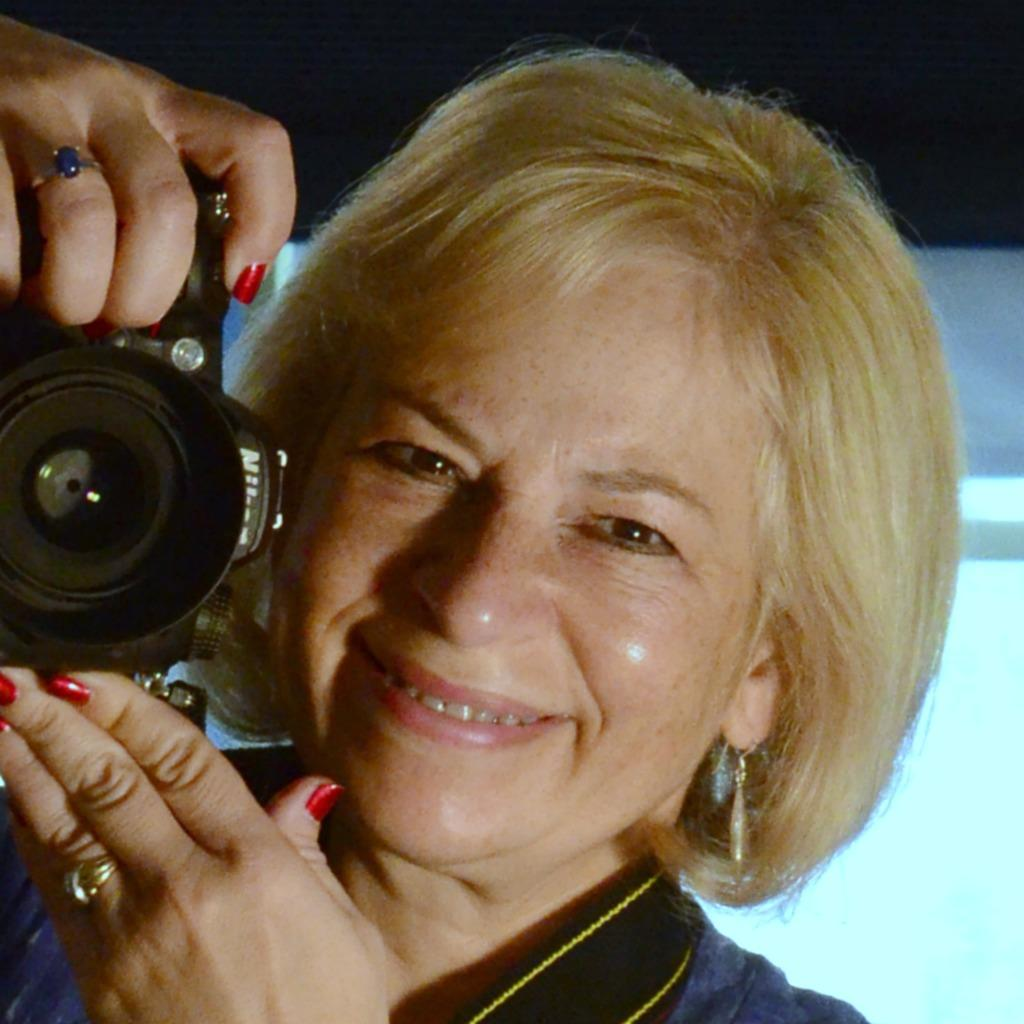Who is present in the image? There is a woman in the image. What is the woman's facial expression? The woman is smiling. What type of accessory is the woman wearing? The woman is wearing earrings. What object is the woman holding in the image? The woman is holding a digital camera. What type of hook can be seen in the image? There is no hook present in the image. 